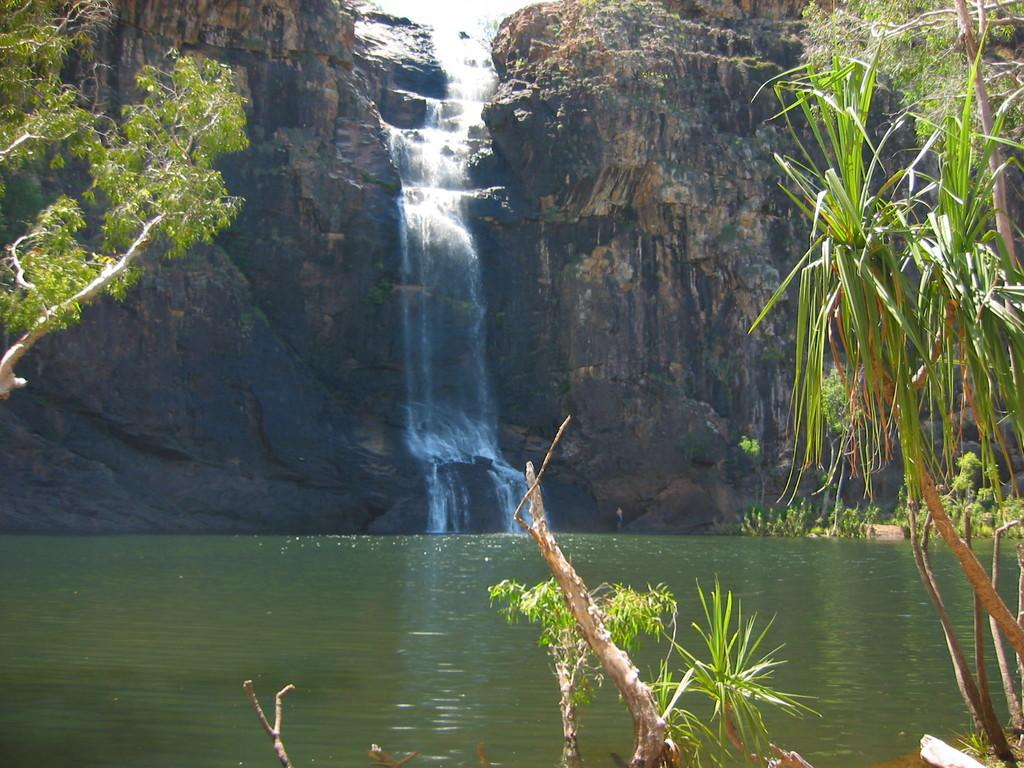What type of vegetation can be seen in the image? There are leaves and branches visible in the image. What natural element is present in the image? There is water visible in the image. What geological feature can be seen in the background of the image? There is a rock in the background of the image. What type of water feature is present in the background of the image? There is a waterfall in the background of the image. What is the skin condition of the leaves in the image? There is no mention of a skin condition in the image, as it features leaves and branches in a natural setting. 